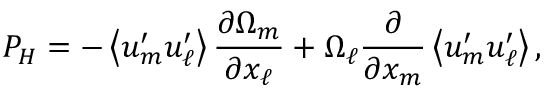<formula> <loc_0><loc_0><loc_500><loc_500>P _ { H } = - \left \langle { u _ { m } ^ { \prime } u _ { \ell } ^ { \prime } } \right \rangle \frac { \partial \Omega _ { m } } { \partial x _ { \ell } } + \Omega _ { \ell } \frac { \partial } { \partial x _ { m } } \left \langle { u _ { m } ^ { \prime } u _ { \ell } ^ { \prime } } \right \rangle ,</formula> 